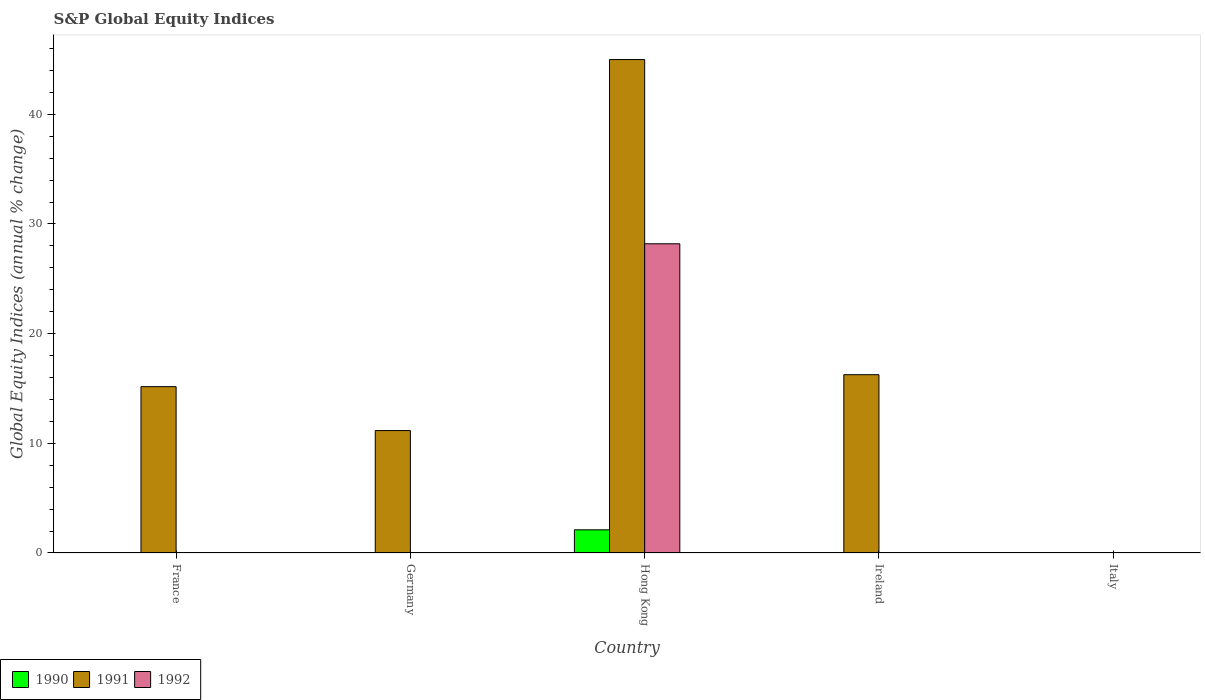Are the number of bars on each tick of the X-axis equal?
Keep it short and to the point. No. How many bars are there on the 5th tick from the left?
Make the answer very short. 0. How many bars are there on the 2nd tick from the right?
Make the answer very short. 1. In how many cases, is the number of bars for a given country not equal to the number of legend labels?
Make the answer very short. 4. Across all countries, what is the maximum global equity indices in 1990?
Provide a short and direct response. 2.11. In which country was the global equity indices in 1990 maximum?
Ensure brevity in your answer.  Hong Kong. What is the total global equity indices in 1990 in the graph?
Offer a terse response. 2.11. What is the difference between the global equity indices in 1991 in Germany and that in Hong Kong?
Ensure brevity in your answer.  -33.83. What is the difference between the global equity indices in 1990 in Ireland and the global equity indices in 1992 in Hong Kong?
Give a very brief answer. -28.19. What is the average global equity indices in 1992 per country?
Your answer should be compact. 5.64. What is the difference between the global equity indices of/in 1990 and global equity indices of/in 1992 in Hong Kong?
Provide a succinct answer. -26.08. What is the ratio of the global equity indices in 1991 in France to that in Hong Kong?
Ensure brevity in your answer.  0.34. What is the difference between the highest and the lowest global equity indices in 1992?
Provide a succinct answer. 28.19. Is the sum of the global equity indices in 1991 in Germany and Hong Kong greater than the maximum global equity indices in 1992 across all countries?
Give a very brief answer. Yes. Are all the bars in the graph horizontal?
Your answer should be compact. No. Does the graph contain grids?
Your answer should be compact. No. How many legend labels are there?
Your answer should be compact. 3. What is the title of the graph?
Ensure brevity in your answer.  S&P Global Equity Indices. What is the label or title of the Y-axis?
Offer a terse response. Global Equity Indices (annual % change). What is the Global Equity Indices (annual % change) in 1990 in France?
Give a very brief answer. 0. What is the Global Equity Indices (annual % change) in 1991 in France?
Your answer should be compact. 15.17. What is the Global Equity Indices (annual % change) of 1990 in Germany?
Provide a succinct answer. 0. What is the Global Equity Indices (annual % change) in 1991 in Germany?
Provide a short and direct response. 11.16. What is the Global Equity Indices (annual % change) of 1990 in Hong Kong?
Give a very brief answer. 2.11. What is the Global Equity Indices (annual % change) of 1991 in Hong Kong?
Offer a very short reply. 44.99. What is the Global Equity Indices (annual % change) in 1992 in Hong Kong?
Provide a succinct answer. 28.19. What is the Global Equity Indices (annual % change) in 1991 in Ireland?
Your answer should be very brief. 16.26. What is the Global Equity Indices (annual % change) in 1992 in Italy?
Your response must be concise. 0. Across all countries, what is the maximum Global Equity Indices (annual % change) in 1990?
Provide a short and direct response. 2.11. Across all countries, what is the maximum Global Equity Indices (annual % change) in 1991?
Make the answer very short. 44.99. Across all countries, what is the maximum Global Equity Indices (annual % change) of 1992?
Your answer should be very brief. 28.19. Across all countries, what is the minimum Global Equity Indices (annual % change) in 1991?
Keep it short and to the point. 0. Across all countries, what is the minimum Global Equity Indices (annual % change) in 1992?
Make the answer very short. 0. What is the total Global Equity Indices (annual % change) in 1990 in the graph?
Provide a succinct answer. 2.11. What is the total Global Equity Indices (annual % change) in 1991 in the graph?
Your answer should be compact. 87.58. What is the total Global Equity Indices (annual % change) in 1992 in the graph?
Offer a very short reply. 28.19. What is the difference between the Global Equity Indices (annual % change) of 1991 in France and that in Germany?
Give a very brief answer. 4. What is the difference between the Global Equity Indices (annual % change) in 1991 in France and that in Hong Kong?
Give a very brief answer. -29.83. What is the difference between the Global Equity Indices (annual % change) in 1991 in France and that in Ireland?
Ensure brevity in your answer.  -1.09. What is the difference between the Global Equity Indices (annual % change) in 1991 in Germany and that in Hong Kong?
Your answer should be compact. -33.83. What is the difference between the Global Equity Indices (annual % change) in 1991 in Germany and that in Ireland?
Your answer should be very brief. -5.09. What is the difference between the Global Equity Indices (annual % change) of 1991 in Hong Kong and that in Ireland?
Provide a short and direct response. 28.74. What is the difference between the Global Equity Indices (annual % change) in 1991 in France and the Global Equity Indices (annual % change) in 1992 in Hong Kong?
Provide a succinct answer. -13.03. What is the difference between the Global Equity Indices (annual % change) in 1991 in Germany and the Global Equity Indices (annual % change) in 1992 in Hong Kong?
Offer a terse response. -17.03. What is the difference between the Global Equity Indices (annual % change) in 1990 in Hong Kong and the Global Equity Indices (annual % change) in 1991 in Ireland?
Offer a terse response. -14.14. What is the average Global Equity Indices (annual % change) in 1990 per country?
Ensure brevity in your answer.  0.42. What is the average Global Equity Indices (annual % change) in 1991 per country?
Ensure brevity in your answer.  17.52. What is the average Global Equity Indices (annual % change) in 1992 per country?
Provide a short and direct response. 5.64. What is the difference between the Global Equity Indices (annual % change) in 1990 and Global Equity Indices (annual % change) in 1991 in Hong Kong?
Provide a succinct answer. -42.88. What is the difference between the Global Equity Indices (annual % change) in 1990 and Global Equity Indices (annual % change) in 1992 in Hong Kong?
Provide a short and direct response. -26.08. What is the difference between the Global Equity Indices (annual % change) of 1991 and Global Equity Indices (annual % change) of 1992 in Hong Kong?
Make the answer very short. 16.8. What is the ratio of the Global Equity Indices (annual % change) of 1991 in France to that in Germany?
Give a very brief answer. 1.36. What is the ratio of the Global Equity Indices (annual % change) of 1991 in France to that in Hong Kong?
Make the answer very short. 0.34. What is the ratio of the Global Equity Indices (annual % change) of 1991 in France to that in Ireland?
Make the answer very short. 0.93. What is the ratio of the Global Equity Indices (annual % change) of 1991 in Germany to that in Hong Kong?
Your response must be concise. 0.25. What is the ratio of the Global Equity Indices (annual % change) in 1991 in Germany to that in Ireland?
Provide a succinct answer. 0.69. What is the ratio of the Global Equity Indices (annual % change) in 1991 in Hong Kong to that in Ireland?
Offer a terse response. 2.77. What is the difference between the highest and the second highest Global Equity Indices (annual % change) in 1991?
Provide a succinct answer. 28.74. What is the difference between the highest and the lowest Global Equity Indices (annual % change) of 1990?
Ensure brevity in your answer.  2.11. What is the difference between the highest and the lowest Global Equity Indices (annual % change) in 1991?
Your response must be concise. 44.99. What is the difference between the highest and the lowest Global Equity Indices (annual % change) in 1992?
Ensure brevity in your answer.  28.19. 